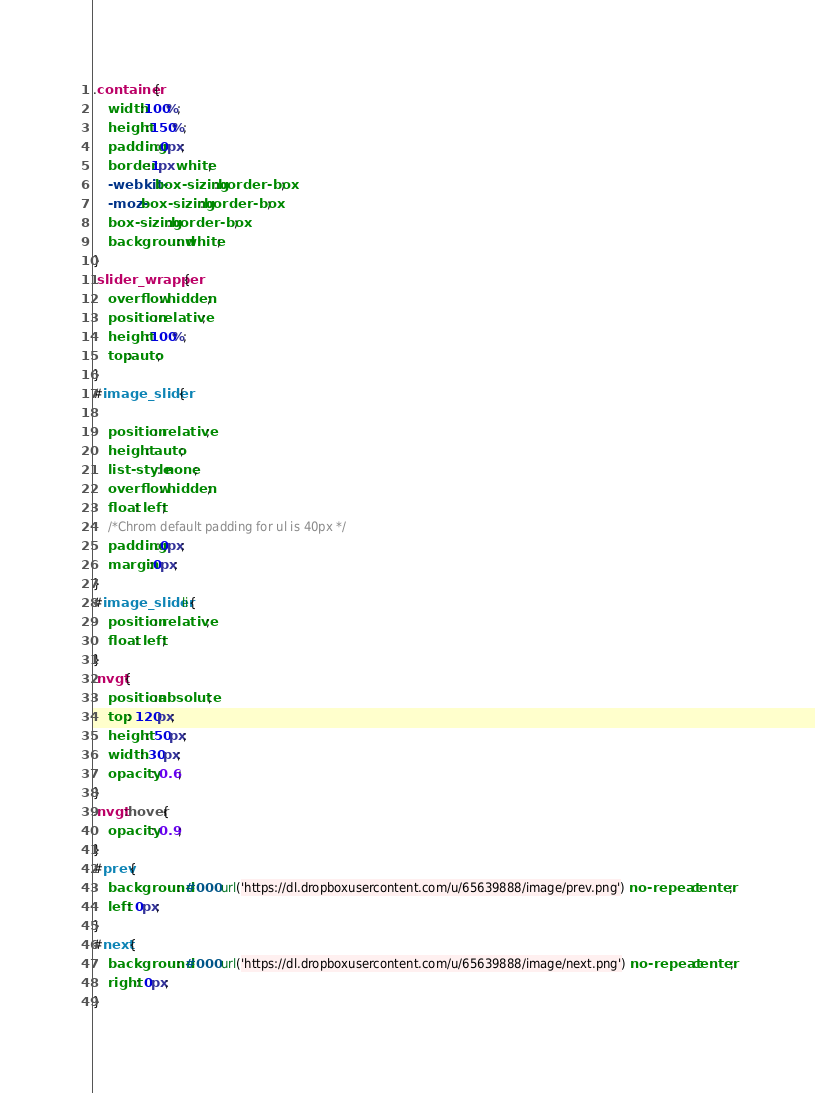<code> <loc_0><loc_0><loc_500><loc_500><_CSS_>.container{
	width:100%;
	height:150%;
	padding:0px;
	border:1px white;
	-webkit-box-sizing:border-box;
	-moz-box-sizing:border-box;
	box-sizing:border-box;
	background: white;	
}
.slider_wrapper{
	overflow: hidden;
	position:relative;
	height:100%;
	top:auto;
}
#image_slider{

	position: relative;
	height: auto;
	list-style: none;
	overflow: hidden;
	float: left;
	/*Chrom default padding for ul is 40px */
	padding:0px;
	margin:0px;
}
#image_slider li{
	position: relative;
	float: left;
}
.nvgt{
	position:absolute;
	top: 120px;
	height: 50px;
	width: 30px;
	opacity: 0.6;
}
.nvgt:hover{
	opacity: 0.9;
}
#prev{
	background: #000 url('https://dl.dropboxusercontent.com/u/65639888/image/prev.png') no-repeat center;
	left: 0px;
}
#next{
	background: #000 url('https://dl.dropboxusercontent.com/u/65639888/image/next.png') no-repeat center;
	right: 0px;
}</code> 